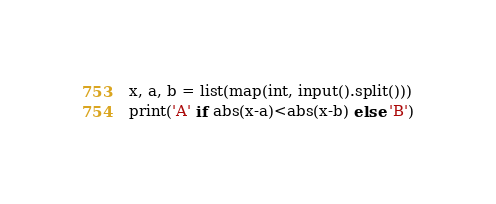<code> <loc_0><loc_0><loc_500><loc_500><_Python_>x, a, b = list(map(int, input().split()))
print('A' if abs(x-a)<abs(x-b) else 'B')</code> 